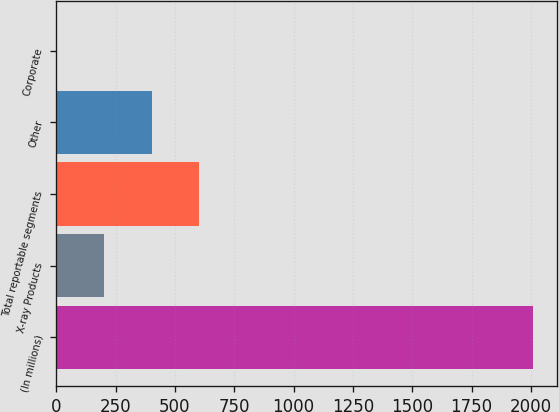<chart> <loc_0><loc_0><loc_500><loc_500><bar_chart><fcel>(In millions)<fcel>X-ray Products<fcel>Total reportable segments<fcel>Other<fcel>Corporate<nl><fcel>2010<fcel>202.03<fcel>603.8<fcel>402.91<fcel>1.15<nl></chart> 